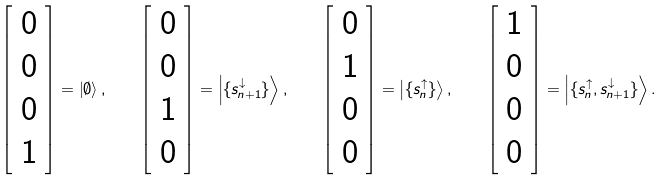Convert formula to latex. <formula><loc_0><loc_0><loc_500><loc_500>\left [ \begin{array} { c } 0 \\ 0 \\ 0 \\ 1 \end{array} \right ] = \left | \emptyset \right \rangle , \quad \left [ \begin{array} { c } 0 \\ 0 \\ 1 \\ 0 \end{array} \right ] = \left | \{ s _ { n + 1 } ^ { \downarrow } \} \right \rangle , \quad \left [ \begin{array} { c } 0 \\ 1 \\ 0 \\ 0 \end{array} \right ] = \left | \{ s _ { n } ^ { \uparrow } \} \right \rangle , \quad \left [ \begin{array} { c } 1 \\ 0 \\ 0 \\ 0 \end{array} \right ] = \left | \{ s _ { n } ^ { \uparrow } , s _ { n + 1 } ^ { \downarrow } \} \right \rangle .</formula> 